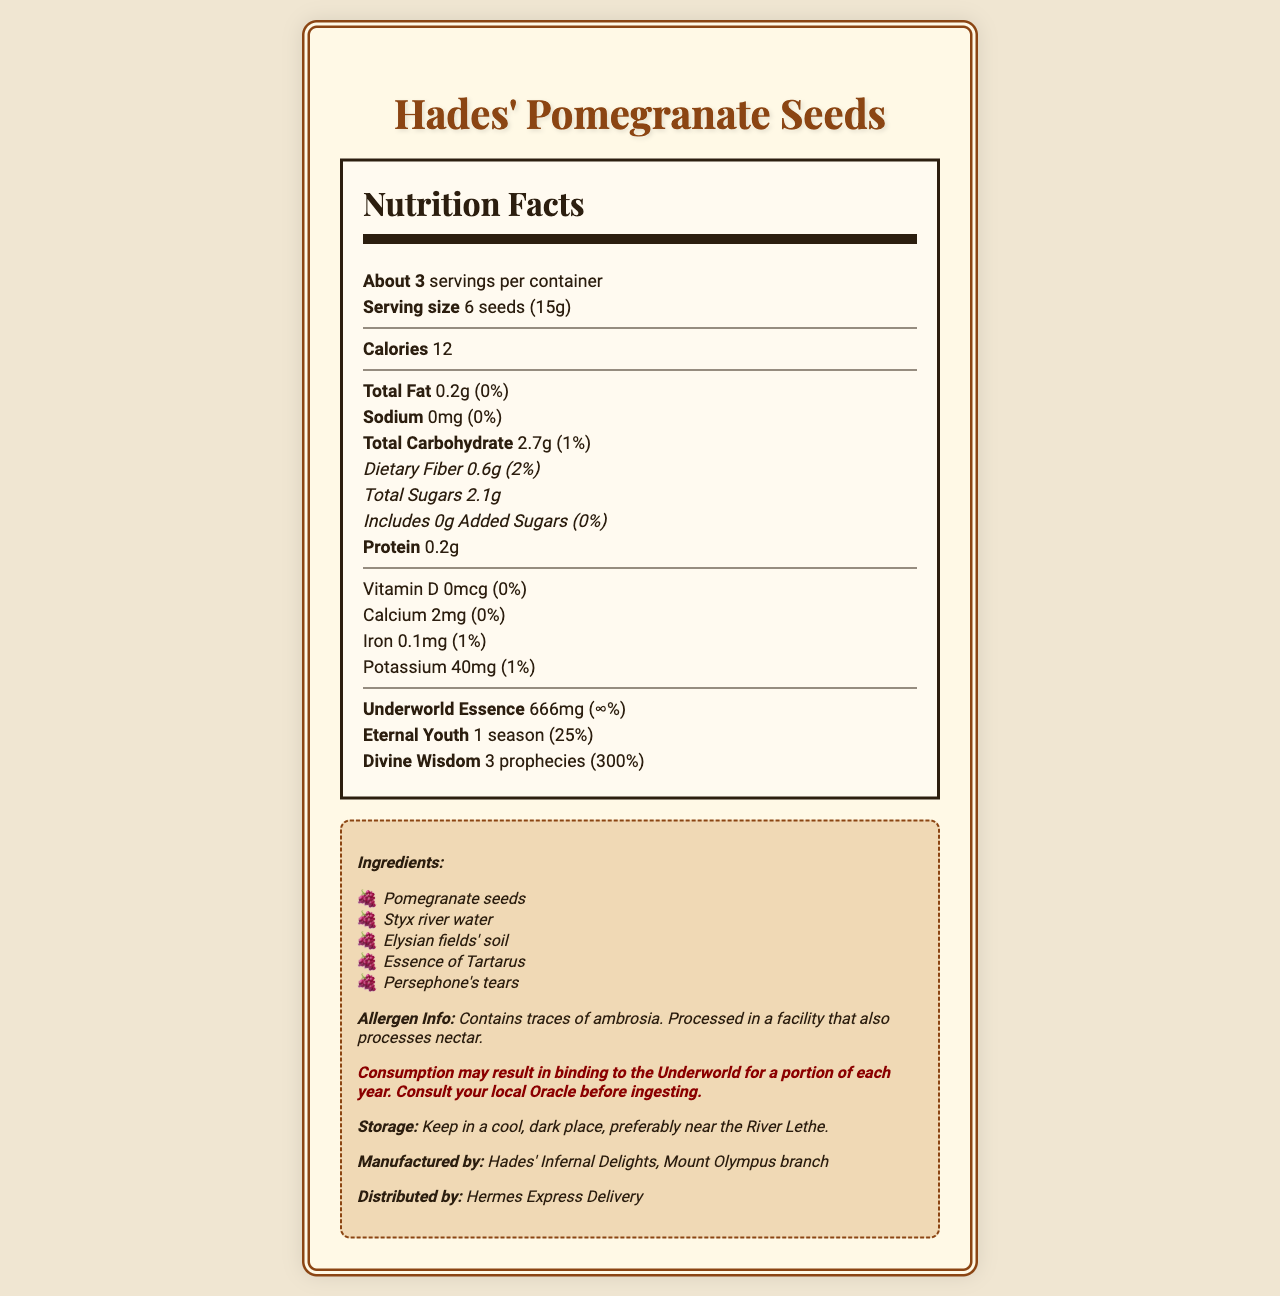what is the serving size for Hades' Pomegranate Seeds? The serving size is listed as 6 seeds (15g) in the nutrition label section.
Answer: 6 seeds (15g) how many servings are there per container? The document states that there are about 3 servings per container in the nutrition label section.
Answer: About 3 what is the total amount of fiber per serving? The dietary fiber per serving is mentioned as 0.6g in the document.
Answer: 0.6g what is the daily value percentage of divine wisdom per serving? The document lists divine wisdom's daily value percentage as 300%.
Answer: 300% what storage conditions are recommended for Hades' Pomegranate Seeds? The storage recommendations are explicitly stated in the document.
Answer: Keep in a cool, dark place, preferably near the River Lethe. what is the main ingredient in Hades' Pomegranate Seeds? A. Pomegranate seeds B. Styx river water C. Elysian fields' soil D. Persephone's tears The main ingredient is pomegranate seeds as they are listed first in the ingredients section.
Answer: A how many calories are in one serving of Hades' Pomegranate Seeds? A. 50 B. 25 C. 12 D. 100 The document states that one serving has 12 calories.
Answer: C is there any added sugar in Hades' Pomegranate Seeds? The document lists "Includes 0g Added Sugars (0%)", indicating no added sugar.
Answer: No does the consumption of Hades' Pomegranate Seeds have any mythological risks? The document mentions a mythological warning about the potential binding to the Underworld.
Answer: Yes summarize the entire document The summary includes the key points: serving size, servings per container, nutritional values, unique properties (underworld essence, eternal youth, divine wisdom), ingredients list, mythological warnings, and storage instructions.
Answer: The document provides the nutrition facts for Hades' Pomegranate Seeds, which have a serving size of 6 seeds (15g) and about 3 servings per container. Each serving has 12 calories, minimal fat, carbohydrates, and protein, and contains unique mythological properties like underworld essence, eternal youth, and divine wisdom. Ingredients include pomegranate seeds, Styx river water, Elysian fields' soil, essence of Tartarus, and Persephone's tears. There is a mythological warning regarding consumption binding one to the Underworld for part of each year. It is recommended to store the seeds in a cool, dark place. who distributes Hades' Pomegranate Seeds? The distributor, Hermes Express Delivery, is mentioned at the bottom of the document.
Answer: Hermes Express Delivery what percentage of the daily value of potassium is in one serving? The daily value of potassium per serving is listed as 1% in the document.
Answer: 1% how much underworld essence is present in each serving? Underworld essence per serving is listed as 666mg in the document.
Answer: 666mg is this product suitable for individuals allergic to ambrosia? The allergen information states that the product contains traces of ambrosia.
Answer: No what is the recommended method for consulting before consuming the product? The mythological warning suggests consulting your local Oracle before ingesting.
Answer: Consult your local Oracle is the manufacturing location of Hades' Pomegranate Seeds mentioned in the document? The document states that the seeds are manufactured by Hades' Infernal Delights, Mount Olympus branch.
Answer: Yes can Hades' Pomegranate Seeds make someone regain eternal youth by consuming one serving daily? The document mentions eternal youth as 1 season with a daily value of 25%, but does not provide sufficient specifics about achieving eternal youth by consuming one serving daily.
Answer: Not enough information which river's water is used in the ingredients of Hades' Pomegranate Seeds? The ingredient list includes Styx river water.
Answer: Styx river 